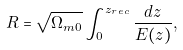<formula> <loc_0><loc_0><loc_500><loc_500>R = \sqrt { \Omega _ { m 0 } } \int _ { 0 } ^ { z _ { r e c } } \frac { d z } { E ( z ) } ,</formula> 